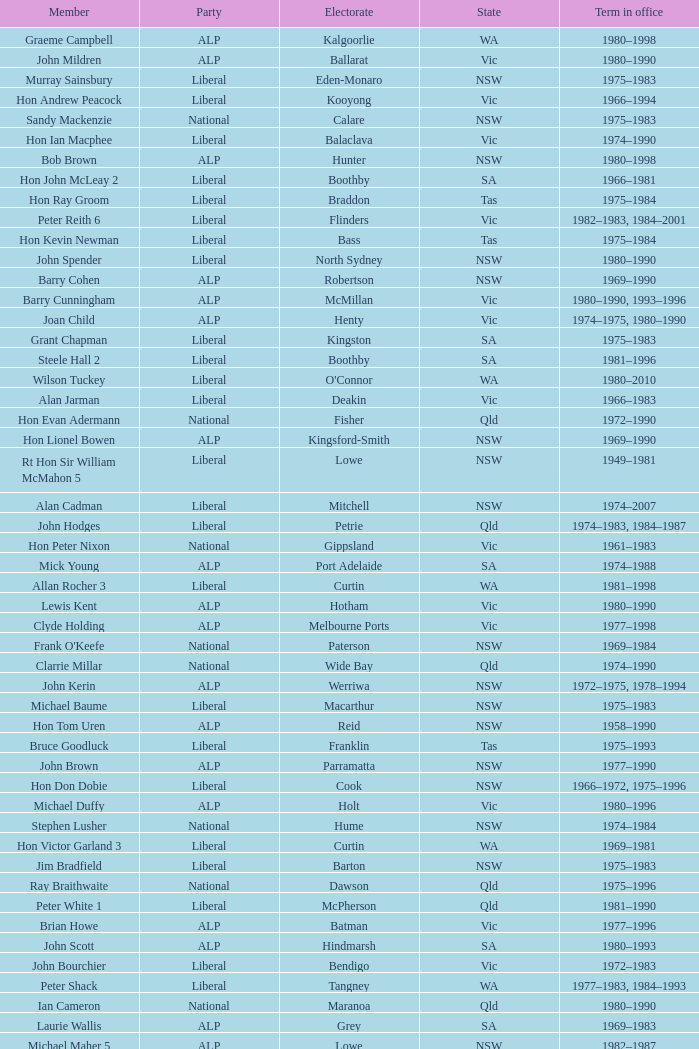What party is Mick Young a member of? ALP. 